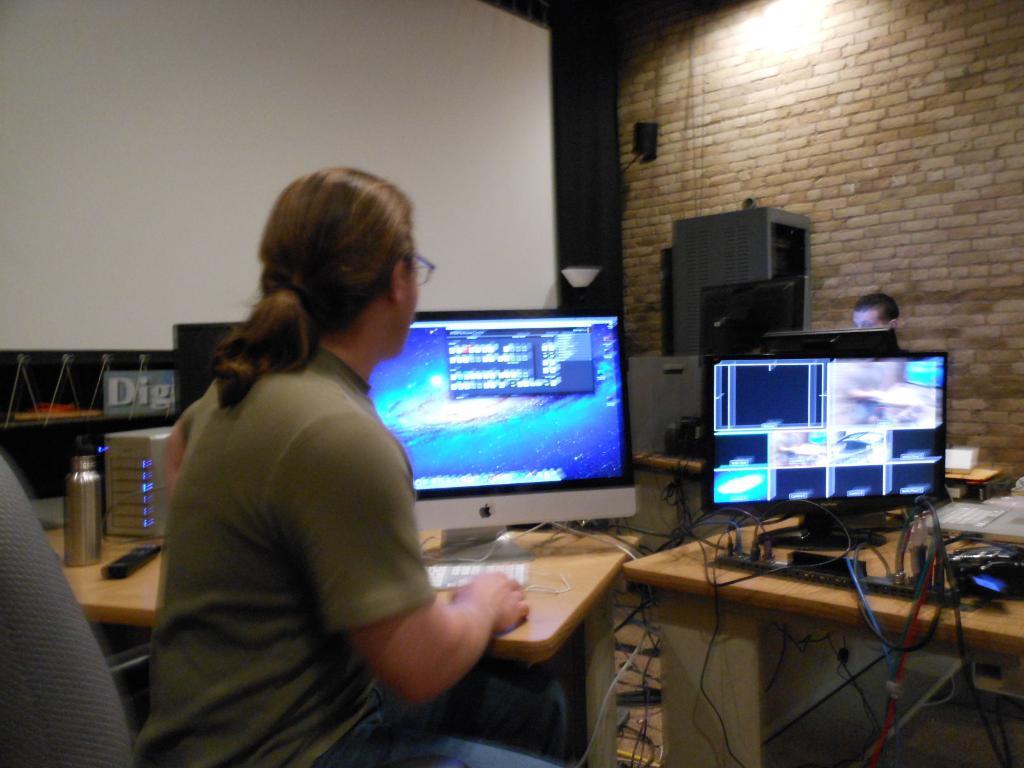What kind of computer is that in from of them?
Provide a succinct answer. Apple. 